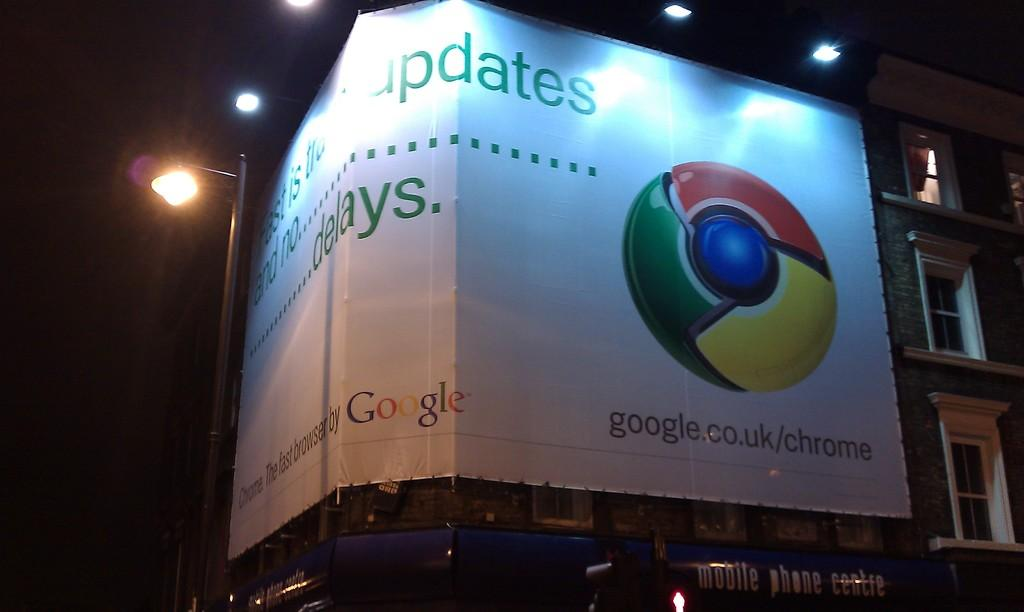<image>
Summarize the visual content of the image. a Google sign is covering the corner of a building 